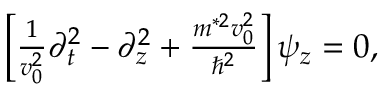Convert formula to latex. <formula><loc_0><loc_0><loc_500><loc_500>\begin{array} { r } { \left [ \frac { 1 } { v _ { 0 } ^ { 2 } } \partial _ { t } ^ { 2 } - \partial _ { z } ^ { 2 } + \frac { m ^ { * 2 } v _ { 0 } ^ { 2 } } { \hbar { ^ } { 2 } } \right ] \psi _ { z } = 0 , } \end{array}</formula> 